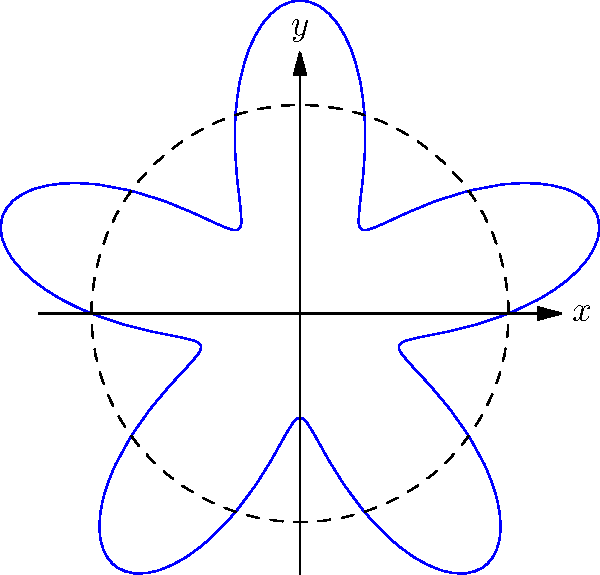As a beginner artist inspired by Berlin's street art, you want to create a simple mandala design using polar coordinates. The equation $r = 2 + \sin(5\theta)$ is used to generate the shape shown above. What is the maximum radius of this mandala design? To find the maximum radius of the mandala design, we need to follow these steps:

1) The general equation for the mandala is given as $r = 2 + \sin(5\theta)$.

2) The sine function always oscillates between -1 and 1. Therefore, $\sin(5\theta)$ will also oscillate between -1 and 1, regardless of the value of $\theta$.

3) The constant term 2 in the equation shifts the entire graph outward by 2 units from the origin.

4) When $\sin(5\theta)$ reaches its maximum value of 1, we get the maximum radius:

   $r_{max} = 2 + 1 = 3$

5) When $\sin(5\theta)$ reaches its minimum value of -1, we get the minimum radius:

   $r_{min} = 2 + (-1) = 1$

6) This explains why the mandala oscillates between the dashed circle (radius 2) and the outer peaks (radius 3).

Therefore, the maximum radius of the mandala design is 3 units.
Answer: 3 